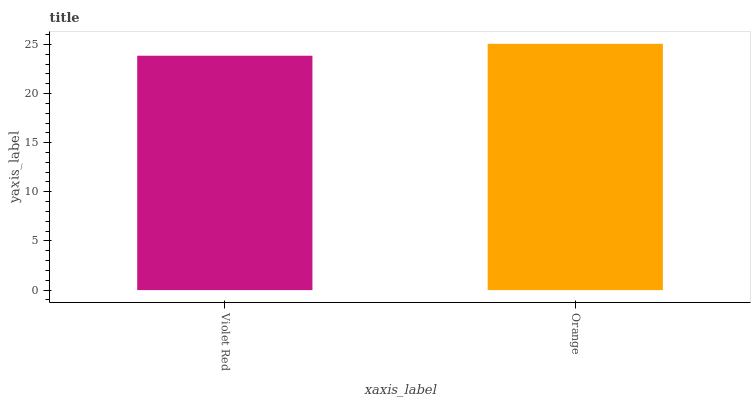Is Orange the minimum?
Answer yes or no. No. Is Orange greater than Violet Red?
Answer yes or no. Yes. Is Violet Red less than Orange?
Answer yes or no. Yes. Is Violet Red greater than Orange?
Answer yes or no. No. Is Orange less than Violet Red?
Answer yes or no. No. Is Orange the high median?
Answer yes or no. Yes. Is Violet Red the low median?
Answer yes or no. Yes. Is Violet Red the high median?
Answer yes or no. No. Is Orange the low median?
Answer yes or no. No. 